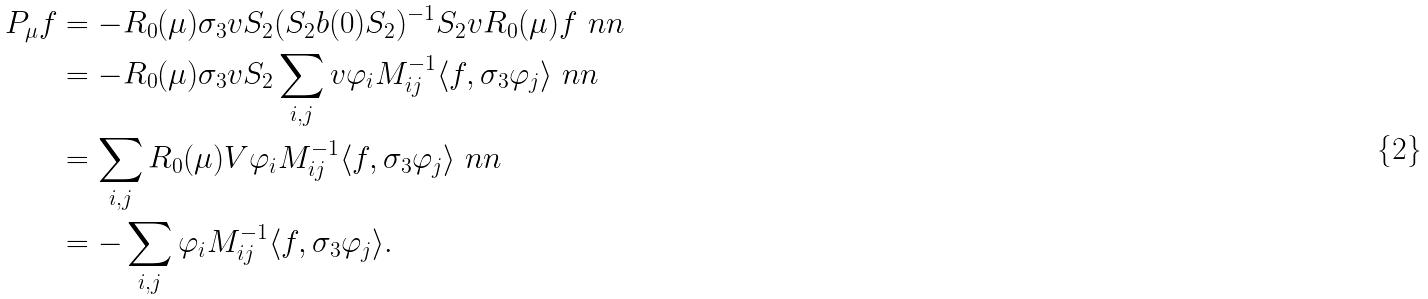Convert formula to latex. <formula><loc_0><loc_0><loc_500><loc_500>P _ { \mu } f & = - R _ { 0 } ( \mu ) \sigma _ { 3 } v S _ { 2 } ( S _ { 2 } b ( 0 ) S _ { 2 } ) ^ { - 1 } S _ { 2 } v R _ { 0 } ( \mu ) f \ n n \\ & = - R _ { 0 } ( \mu ) \sigma _ { 3 } v S _ { 2 } \sum _ { i , j } v \varphi _ { i } M ^ { - 1 } _ { i j } \langle f , \sigma _ { 3 } \varphi _ { j } \rangle \ n n \\ & = \sum _ { i , j } R _ { 0 } ( \mu ) V \varphi _ { i } M ^ { - 1 } _ { i j } \langle f , \sigma _ { 3 } \varphi _ { j } \rangle \ n n \\ & = - \sum _ { i , j } \varphi _ { i } M ^ { - 1 } _ { i j } \langle f , \sigma _ { 3 } \varphi _ { j } \rangle .</formula> 